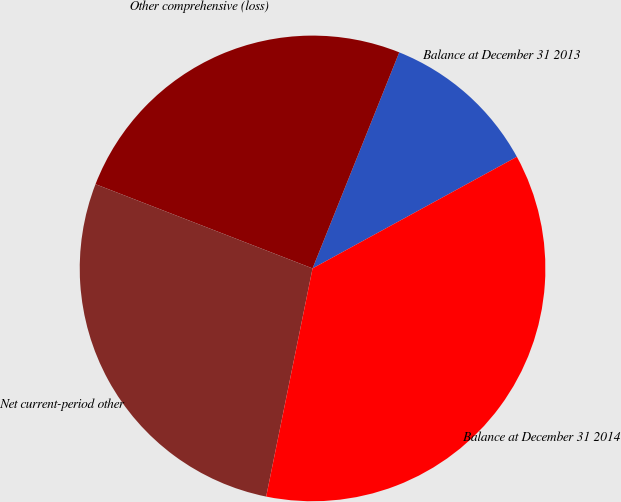Convert chart to OTSL. <chart><loc_0><loc_0><loc_500><loc_500><pie_chart><fcel>Balance at December 31 2013<fcel>Other comprehensive (loss)<fcel>Net current-period other<fcel>Balance at December 31 2014<nl><fcel>10.97%<fcel>25.18%<fcel>27.7%<fcel>36.15%<nl></chart> 